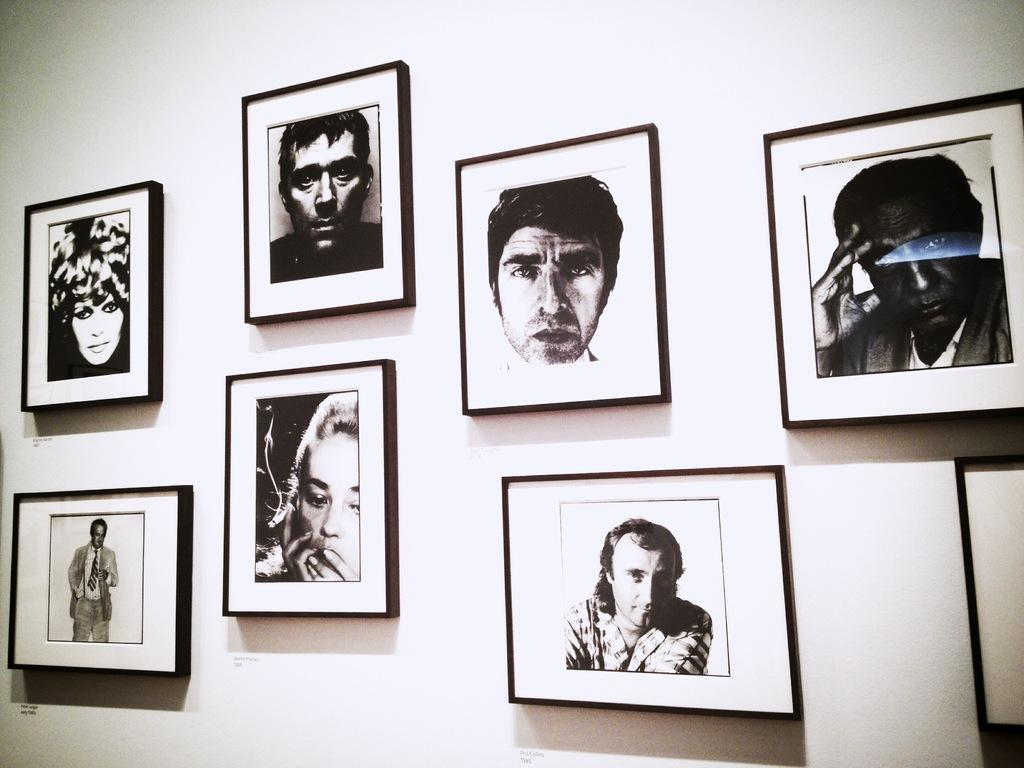What is hanging on the wall in the image? There are photo frames on the wall in the image. What can be seen inside the photo frames? The photo frames contain images of men and women. What is the color scheme of the image? The image is black and white. Can you tell me how many porters are visible in the image? There are no porters present in the image. What type of farm can be seen in the background of the image? There is no farm visible in the image; it features photo frames on a wall. 